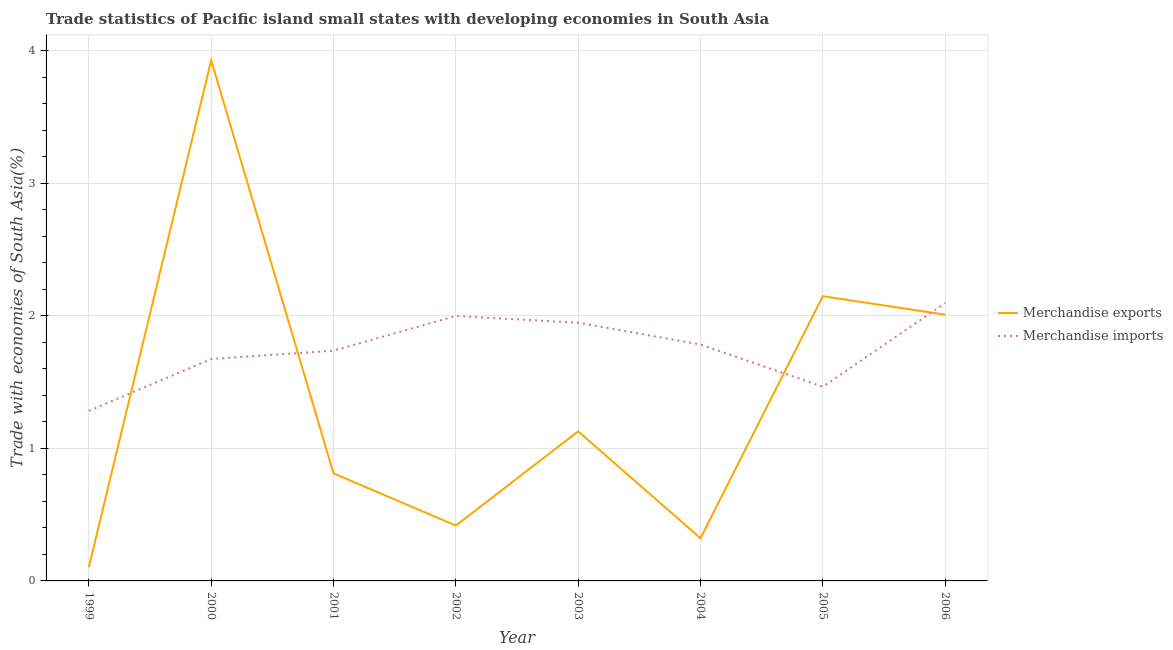How many different coloured lines are there?
Provide a succinct answer. 2. What is the merchandise exports in 2005?
Provide a succinct answer. 2.15. Across all years, what is the maximum merchandise imports?
Keep it short and to the point. 2.09. Across all years, what is the minimum merchandise exports?
Your response must be concise. 0.1. In which year was the merchandise imports maximum?
Your answer should be very brief. 2006. What is the total merchandise imports in the graph?
Your answer should be compact. 13.98. What is the difference between the merchandise imports in 2004 and that in 2005?
Keep it short and to the point. 0.32. What is the difference between the merchandise exports in 1999 and the merchandise imports in 2005?
Provide a succinct answer. -1.36. What is the average merchandise exports per year?
Your answer should be very brief. 1.36. In the year 2002, what is the difference between the merchandise imports and merchandise exports?
Your response must be concise. 1.58. In how many years, is the merchandise imports greater than 1.6 %?
Provide a succinct answer. 6. What is the ratio of the merchandise exports in 1999 to that in 2001?
Your response must be concise. 0.13. Is the merchandise imports in 2000 less than that in 2001?
Your response must be concise. Yes. Is the difference between the merchandise imports in 1999 and 2000 greater than the difference between the merchandise exports in 1999 and 2000?
Your answer should be compact. Yes. What is the difference between the highest and the second highest merchandise imports?
Offer a very short reply. 0.1. What is the difference between the highest and the lowest merchandise imports?
Ensure brevity in your answer.  0.81. In how many years, is the merchandise exports greater than the average merchandise exports taken over all years?
Your answer should be very brief. 3. Is the sum of the merchandise exports in 2001 and 2003 greater than the maximum merchandise imports across all years?
Make the answer very short. No. Does the merchandise exports monotonically increase over the years?
Offer a terse response. No. Is the merchandise exports strictly less than the merchandise imports over the years?
Make the answer very short. No. Where does the legend appear in the graph?
Offer a very short reply. Center right. How many legend labels are there?
Offer a terse response. 2. How are the legend labels stacked?
Ensure brevity in your answer.  Vertical. What is the title of the graph?
Your answer should be very brief. Trade statistics of Pacific island small states with developing economies in South Asia. What is the label or title of the X-axis?
Offer a terse response. Year. What is the label or title of the Y-axis?
Your answer should be compact. Trade with economies of South Asia(%). What is the Trade with economies of South Asia(%) in Merchandise exports in 1999?
Provide a short and direct response. 0.1. What is the Trade with economies of South Asia(%) of Merchandise imports in 1999?
Provide a succinct answer. 1.28. What is the Trade with economies of South Asia(%) of Merchandise exports in 2000?
Provide a succinct answer. 3.93. What is the Trade with economies of South Asia(%) in Merchandise imports in 2000?
Your answer should be compact. 1.67. What is the Trade with economies of South Asia(%) of Merchandise exports in 2001?
Offer a very short reply. 0.81. What is the Trade with economies of South Asia(%) of Merchandise imports in 2001?
Offer a very short reply. 1.74. What is the Trade with economies of South Asia(%) of Merchandise exports in 2002?
Offer a very short reply. 0.42. What is the Trade with economies of South Asia(%) in Merchandise imports in 2002?
Give a very brief answer. 2. What is the Trade with economies of South Asia(%) in Merchandise exports in 2003?
Your answer should be compact. 1.13. What is the Trade with economies of South Asia(%) in Merchandise imports in 2003?
Provide a succinct answer. 1.95. What is the Trade with economies of South Asia(%) in Merchandise exports in 2004?
Offer a very short reply. 0.32. What is the Trade with economies of South Asia(%) of Merchandise imports in 2004?
Give a very brief answer. 1.78. What is the Trade with economies of South Asia(%) in Merchandise exports in 2005?
Your answer should be very brief. 2.15. What is the Trade with economies of South Asia(%) of Merchandise imports in 2005?
Provide a succinct answer. 1.46. What is the Trade with economies of South Asia(%) of Merchandise exports in 2006?
Make the answer very short. 2.01. What is the Trade with economies of South Asia(%) in Merchandise imports in 2006?
Offer a terse response. 2.09. Across all years, what is the maximum Trade with economies of South Asia(%) of Merchandise exports?
Make the answer very short. 3.93. Across all years, what is the maximum Trade with economies of South Asia(%) in Merchandise imports?
Offer a terse response. 2.09. Across all years, what is the minimum Trade with economies of South Asia(%) in Merchandise exports?
Your answer should be compact. 0.1. Across all years, what is the minimum Trade with economies of South Asia(%) in Merchandise imports?
Offer a terse response. 1.28. What is the total Trade with economies of South Asia(%) in Merchandise exports in the graph?
Your answer should be very brief. 10.86. What is the total Trade with economies of South Asia(%) of Merchandise imports in the graph?
Your response must be concise. 13.98. What is the difference between the Trade with economies of South Asia(%) of Merchandise exports in 1999 and that in 2000?
Give a very brief answer. -3.82. What is the difference between the Trade with economies of South Asia(%) of Merchandise imports in 1999 and that in 2000?
Your answer should be compact. -0.39. What is the difference between the Trade with economies of South Asia(%) in Merchandise exports in 1999 and that in 2001?
Ensure brevity in your answer.  -0.71. What is the difference between the Trade with economies of South Asia(%) of Merchandise imports in 1999 and that in 2001?
Ensure brevity in your answer.  -0.45. What is the difference between the Trade with economies of South Asia(%) in Merchandise exports in 1999 and that in 2002?
Your answer should be compact. -0.31. What is the difference between the Trade with economies of South Asia(%) of Merchandise imports in 1999 and that in 2002?
Ensure brevity in your answer.  -0.72. What is the difference between the Trade with economies of South Asia(%) in Merchandise exports in 1999 and that in 2003?
Give a very brief answer. -1.02. What is the difference between the Trade with economies of South Asia(%) in Merchandise imports in 1999 and that in 2003?
Ensure brevity in your answer.  -0.66. What is the difference between the Trade with economies of South Asia(%) in Merchandise exports in 1999 and that in 2004?
Your response must be concise. -0.22. What is the difference between the Trade with economies of South Asia(%) of Merchandise imports in 1999 and that in 2004?
Provide a short and direct response. -0.5. What is the difference between the Trade with economies of South Asia(%) in Merchandise exports in 1999 and that in 2005?
Give a very brief answer. -2.04. What is the difference between the Trade with economies of South Asia(%) of Merchandise imports in 1999 and that in 2005?
Make the answer very short. -0.18. What is the difference between the Trade with economies of South Asia(%) of Merchandise exports in 1999 and that in 2006?
Your answer should be very brief. -1.9. What is the difference between the Trade with economies of South Asia(%) of Merchandise imports in 1999 and that in 2006?
Provide a succinct answer. -0.81. What is the difference between the Trade with economies of South Asia(%) of Merchandise exports in 2000 and that in 2001?
Your answer should be very brief. 3.12. What is the difference between the Trade with economies of South Asia(%) of Merchandise imports in 2000 and that in 2001?
Your answer should be very brief. -0.06. What is the difference between the Trade with economies of South Asia(%) in Merchandise exports in 2000 and that in 2002?
Provide a short and direct response. 3.51. What is the difference between the Trade with economies of South Asia(%) of Merchandise imports in 2000 and that in 2002?
Give a very brief answer. -0.32. What is the difference between the Trade with economies of South Asia(%) of Merchandise exports in 2000 and that in 2003?
Your answer should be compact. 2.8. What is the difference between the Trade with economies of South Asia(%) in Merchandise imports in 2000 and that in 2003?
Offer a very short reply. -0.27. What is the difference between the Trade with economies of South Asia(%) of Merchandise exports in 2000 and that in 2004?
Provide a succinct answer. 3.6. What is the difference between the Trade with economies of South Asia(%) of Merchandise imports in 2000 and that in 2004?
Provide a succinct answer. -0.11. What is the difference between the Trade with economies of South Asia(%) in Merchandise exports in 2000 and that in 2005?
Make the answer very short. 1.78. What is the difference between the Trade with economies of South Asia(%) in Merchandise imports in 2000 and that in 2005?
Your answer should be very brief. 0.21. What is the difference between the Trade with economies of South Asia(%) of Merchandise exports in 2000 and that in 2006?
Offer a very short reply. 1.92. What is the difference between the Trade with economies of South Asia(%) in Merchandise imports in 2000 and that in 2006?
Ensure brevity in your answer.  -0.42. What is the difference between the Trade with economies of South Asia(%) of Merchandise exports in 2001 and that in 2002?
Provide a short and direct response. 0.39. What is the difference between the Trade with economies of South Asia(%) in Merchandise imports in 2001 and that in 2002?
Make the answer very short. -0.26. What is the difference between the Trade with economies of South Asia(%) in Merchandise exports in 2001 and that in 2003?
Offer a terse response. -0.32. What is the difference between the Trade with economies of South Asia(%) of Merchandise imports in 2001 and that in 2003?
Offer a very short reply. -0.21. What is the difference between the Trade with economies of South Asia(%) in Merchandise exports in 2001 and that in 2004?
Ensure brevity in your answer.  0.49. What is the difference between the Trade with economies of South Asia(%) in Merchandise imports in 2001 and that in 2004?
Offer a very short reply. -0.05. What is the difference between the Trade with economies of South Asia(%) in Merchandise exports in 2001 and that in 2005?
Give a very brief answer. -1.34. What is the difference between the Trade with economies of South Asia(%) of Merchandise imports in 2001 and that in 2005?
Offer a terse response. 0.27. What is the difference between the Trade with economies of South Asia(%) of Merchandise exports in 2001 and that in 2006?
Provide a short and direct response. -1.2. What is the difference between the Trade with economies of South Asia(%) in Merchandise imports in 2001 and that in 2006?
Offer a terse response. -0.36. What is the difference between the Trade with economies of South Asia(%) of Merchandise exports in 2002 and that in 2003?
Offer a very short reply. -0.71. What is the difference between the Trade with economies of South Asia(%) in Merchandise imports in 2002 and that in 2003?
Your answer should be compact. 0.05. What is the difference between the Trade with economies of South Asia(%) in Merchandise exports in 2002 and that in 2004?
Keep it short and to the point. 0.1. What is the difference between the Trade with economies of South Asia(%) in Merchandise imports in 2002 and that in 2004?
Provide a short and direct response. 0.22. What is the difference between the Trade with economies of South Asia(%) of Merchandise exports in 2002 and that in 2005?
Offer a terse response. -1.73. What is the difference between the Trade with economies of South Asia(%) in Merchandise imports in 2002 and that in 2005?
Make the answer very short. 0.53. What is the difference between the Trade with economies of South Asia(%) of Merchandise exports in 2002 and that in 2006?
Provide a succinct answer. -1.59. What is the difference between the Trade with economies of South Asia(%) in Merchandise imports in 2002 and that in 2006?
Ensure brevity in your answer.  -0.1. What is the difference between the Trade with economies of South Asia(%) in Merchandise exports in 2003 and that in 2004?
Your answer should be compact. 0.81. What is the difference between the Trade with economies of South Asia(%) in Merchandise imports in 2003 and that in 2004?
Give a very brief answer. 0.16. What is the difference between the Trade with economies of South Asia(%) in Merchandise exports in 2003 and that in 2005?
Ensure brevity in your answer.  -1.02. What is the difference between the Trade with economies of South Asia(%) in Merchandise imports in 2003 and that in 2005?
Your response must be concise. 0.48. What is the difference between the Trade with economies of South Asia(%) in Merchandise exports in 2003 and that in 2006?
Offer a terse response. -0.88. What is the difference between the Trade with economies of South Asia(%) of Merchandise imports in 2003 and that in 2006?
Ensure brevity in your answer.  -0.15. What is the difference between the Trade with economies of South Asia(%) in Merchandise exports in 2004 and that in 2005?
Offer a terse response. -1.83. What is the difference between the Trade with economies of South Asia(%) of Merchandise imports in 2004 and that in 2005?
Make the answer very short. 0.32. What is the difference between the Trade with economies of South Asia(%) of Merchandise exports in 2004 and that in 2006?
Make the answer very short. -1.69. What is the difference between the Trade with economies of South Asia(%) in Merchandise imports in 2004 and that in 2006?
Provide a succinct answer. -0.31. What is the difference between the Trade with economies of South Asia(%) in Merchandise exports in 2005 and that in 2006?
Offer a very short reply. 0.14. What is the difference between the Trade with economies of South Asia(%) in Merchandise imports in 2005 and that in 2006?
Ensure brevity in your answer.  -0.63. What is the difference between the Trade with economies of South Asia(%) in Merchandise exports in 1999 and the Trade with economies of South Asia(%) in Merchandise imports in 2000?
Offer a terse response. -1.57. What is the difference between the Trade with economies of South Asia(%) of Merchandise exports in 1999 and the Trade with economies of South Asia(%) of Merchandise imports in 2001?
Provide a succinct answer. -1.63. What is the difference between the Trade with economies of South Asia(%) in Merchandise exports in 1999 and the Trade with economies of South Asia(%) in Merchandise imports in 2002?
Provide a short and direct response. -1.89. What is the difference between the Trade with economies of South Asia(%) in Merchandise exports in 1999 and the Trade with economies of South Asia(%) in Merchandise imports in 2003?
Your answer should be compact. -1.84. What is the difference between the Trade with economies of South Asia(%) in Merchandise exports in 1999 and the Trade with economies of South Asia(%) in Merchandise imports in 2004?
Keep it short and to the point. -1.68. What is the difference between the Trade with economies of South Asia(%) in Merchandise exports in 1999 and the Trade with economies of South Asia(%) in Merchandise imports in 2005?
Offer a terse response. -1.36. What is the difference between the Trade with economies of South Asia(%) of Merchandise exports in 1999 and the Trade with economies of South Asia(%) of Merchandise imports in 2006?
Your response must be concise. -1.99. What is the difference between the Trade with economies of South Asia(%) of Merchandise exports in 2000 and the Trade with economies of South Asia(%) of Merchandise imports in 2001?
Provide a succinct answer. 2.19. What is the difference between the Trade with economies of South Asia(%) of Merchandise exports in 2000 and the Trade with economies of South Asia(%) of Merchandise imports in 2002?
Provide a succinct answer. 1.93. What is the difference between the Trade with economies of South Asia(%) of Merchandise exports in 2000 and the Trade with economies of South Asia(%) of Merchandise imports in 2003?
Your response must be concise. 1.98. What is the difference between the Trade with economies of South Asia(%) of Merchandise exports in 2000 and the Trade with economies of South Asia(%) of Merchandise imports in 2004?
Keep it short and to the point. 2.14. What is the difference between the Trade with economies of South Asia(%) in Merchandise exports in 2000 and the Trade with economies of South Asia(%) in Merchandise imports in 2005?
Provide a succinct answer. 2.46. What is the difference between the Trade with economies of South Asia(%) of Merchandise exports in 2000 and the Trade with economies of South Asia(%) of Merchandise imports in 2006?
Ensure brevity in your answer.  1.83. What is the difference between the Trade with economies of South Asia(%) of Merchandise exports in 2001 and the Trade with economies of South Asia(%) of Merchandise imports in 2002?
Offer a terse response. -1.19. What is the difference between the Trade with economies of South Asia(%) of Merchandise exports in 2001 and the Trade with economies of South Asia(%) of Merchandise imports in 2003?
Provide a short and direct response. -1.14. What is the difference between the Trade with economies of South Asia(%) of Merchandise exports in 2001 and the Trade with economies of South Asia(%) of Merchandise imports in 2004?
Offer a terse response. -0.97. What is the difference between the Trade with economies of South Asia(%) in Merchandise exports in 2001 and the Trade with economies of South Asia(%) in Merchandise imports in 2005?
Your response must be concise. -0.65. What is the difference between the Trade with economies of South Asia(%) in Merchandise exports in 2001 and the Trade with economies of South Asia(%) in Merchandise imports in 2006?
Keep it short and to the point. -1.28. What is the difference between the Trade with economies of South Asia(%) in Merchandise exports in 2002 and the Trade with economies of South Asia(%) in Merchandise imports in 2003?
Keep it short and to the point. -1.53. What is the difference between the Trade with economies of South Asia(%) of Merchandise exports in 2002 and the Trade with economies of South Asia(%) of Merchandise imports in 2004?
Provide a short and direct response. -1.37. What is the difference between the Trade with economies of South Asia(%) of Merchandise exports in 2002 and the Trade with economies of South Asia(%) of Merchandise imports in 2005?
Your response must be concise. -1.05. What is the difference between the Trade with economies of South Asia(%) of Merchandise exports in 2002 and the Trade with economies of South Asia(%) of Merchandise imports in 2006?
Provide a short and direct response. -1.68. What is the difference between the Trade with economies of South Asia(%) of Merchandise exports in 2003 and the Trade with economies of South Asia(%) of Merchandise imports in 2004?
Your answer should be very brief. -0.65. What is the difference between the Trade with economies of South Asia(%) in Merchandise exports in 2003 and the Trade with economies of South Asia(%) in Merchandise imports in 2005?
Offer a very short reply. -0.34. What is the difference between the Trade with economies of South Asia(%) of Merchandise exports in 2003 and the Trade with economies of South Asia(%) of Merchandise imports in 2006?
Give a very brief answer. -0.97. What is the difference between the Trade with economies of South Asia(%) of Merchandise exports in 2004 and the Trade with economies of South Asia(%) of Merchandise imports in 2005?
Ensure brevity in your answer.  -1.14. What is the difference between the Trade with economies of South Asia(%) of Merchandise exports in 2004 and the Trade with economies of South Asia(%) of Merchandise imports in 2006?
Your answer should be very brief. -1.77. What is the difference between the Trade with economies of South Asia(%) in Merchandise exports in 2005 and the Trade with economies of South Asia(%) in Merchandise imports in 2006?
Keep it short and to the point. 0.05. What is the average Trade with economies of South Asia(%) of Merchandise exports per year?
Offer a terse response. 1.36. What is the average Trade with economies of South Asia(%) of Merchandise imports per year?
Keep it short and to the point. 1.75. In the year 1999, what is the difference between the Trade with economies of South Asia(%) of Merchandise exports and Trade with economies of South Asia(%) of Merchandise imports?
Ensure brevity in your answer.  -1.18. In the year 2000, what is the difference between the Trade with economies of South Asia(%) in Merchandise exports and Trade with economies of South Asia(%) in Merchandise imports?
Your answer should be compact. 2.25. In the year 2001, what is the difference between the Trade with economies of South Asia(%) in Merchandise exports and Trade with economies of South Asia(%) in Merchandise imports?
Keep it short and to the point. -0.93. In the year 2002, what is the difference between the Trade with economies of South Asia(%) in Merchandise exports and Trade with economies of South Asia(%) in Merchandise imports?
Provide a succinct answer. -1.58. In the year 2003, what is the difference between the Trade with economies of South Asia(%) of Merchandise exports and Trade with economies of South Asia(%) of Merchandise imports?
Your answer should be compact. -0.82. In the year 2004, what is the difference between the Trade with economies of South Asia(%) of Merchandise exports and Trade with economies of South Asia(%) of Merchandise imports?
Your answer should be compact. -1.46. In the year 2005, what is the difference between the Trade with economies of South Asia(%) in Merchandise exports and Trade with economies of South Asia(%) in Merchandise imports?
Keep it short and to the point. 0.68. In the year 2006, what is the difference between the Trade with economies of South Asia(%) of Merchandise exports and Trade with economies of South Asia(%) of Merchandise imports?
Your answer should be very brief. -0.09. What is the ratio of the Trade with economies of South Asia(%) of Merchandise exports in 1999 to that in 2000?
Offer a very short reply. 0.03. What is the ratio of the Trade with economies of South Asia(%) in Merchandise imports in 1999 to that in 2000?
Your answer should be compact. 0.77. What is the ratio of the Trade with economies of South Asia(%) in Merchandise exports in 1999 to that in 2001?
Keep it short and to the point. 0.13. What is the ratio of the Trade with economies of South Asia(%) in Merchandise imports in 1999 to that in 2001?
Your answer should be compact. 0.74. What is the ratio of the Trade with economies of South Asia(%) of Merchandise exports in 1999 to that in 2002?
Make the answer very short. 0.25. What is the ratio of the Trade with economies of South Asia(%) in Merchandise imports in 1999 to that in 2002?
Keep it short and to the point. 0.64. What is the ratio of the Trade with economies of South Asia(%) in Merchandise exports in 1999 to that in 2003?
Your response must be concise. 0.09. What is the ratio of the Trade with economies of South Asia(%) in Merchandise imports in 1999 to that in 2003?
Make the answer very short. 0.66. What is the ratio of the Trade with economies of South Asia(%) in Merchandise exports in 1999 to that in 2004?
Provide a succinct answer. 0.32. What is the ratio of the Trade with economies of South Asia(%) of Merchandise imports in 1999 to that in 2004?
Your answer should be very brief. 0.72. What is the ratio of the Trade with economies of South Asia(%) in Merchandise exports in 1999 to that in 2005?
Keep it short and to the point. 0.05. What is the ratio of the Trade with economies of South Asia(%) of Merchandise imports in 1999 to that in 2005?
Your answer should be very brief. 0.88. What is the ratio of the Trade with economies of South Asia(%) in Merchandise exports in 1999 to that in 2006?
Your response must be concise. 0.05. What is the ratio of the Trade with economies of South Asia(%) of Merchandise imports in 1999 to that in 2006?
Offer a terse response. 0.61. What is the ratio of the Trade with economies of South Asia(%) in Merchandise exports in 2000 to that in 2001?
Provide a succinct answer. 4.84. What is the ratio of the Trade with economies of South Asia(%) of Merchandise imports in 2000 to that in 2001?
Offer a terse response. 0.96. What is the ratio of the Trade with economies of South Asia(%) in Merchandise exports in 2000 to that in 2002?
Your response must be concise. 9.41. What is the ratio of the Trade with economies of South Asia(%) of Merchandise imports in 2000 to that in 2002?
Ensure brevity in your answer.  0.84. What is the ratio of the Trade with economies of South Asia(%) of Merchandise exports in 2000 to that in 2003?
Your answer should be very brief. 3.48. What is the ratio of the Trade with economies of South Asia(%) in Merchandise imports in 2000 to that in 2003?
Your answer should be very brief. 0.86. What is the ratio of the Trade with economies of South Asia(%) of Merchandise exports in 2000 to that in 2004?
Provide a short and direct response. 12.2. What is the ratio of the Trade with economies of South Asia(%) in Merchandise imports in 2000 to that in 2004?
Offer a very short reply. 0.94. What is the ratio of the Trade with economies of South Asia(%) of Merchandise exports in 2000 to that in 2005?
Give a very brief answer. 1.83. What is the ratio of the Trade with economies of South Asia(%) of Merchandise imports in 2000 to that in 2005?
Give a very brief answer. 1.14. What is the ratio of the Trade with economies of South Asia(%) in Merchandise exports in 2000 to that in 2006?
Your answer should be very brief. 1.96. What is the ratio of the Trade with economies of South Asia(%) of Merchandise imports in 2000 to that in 2006?
Offer a terse response. 0.8. What is the ratio of the Trade with economies of South Asia(%) in Merchandise exports in 2001 to that in 2002?
Make the answer very short. 1.94. What is the ratio of the Trade with economies of South Asia(%) of Merchandise imports in 2001 to that in 2002?
Keep it short and to the point. 0.87. What is the ratio of the Trade with economies of South Asia(%) in Merchandise exports in 2001 to that in 2003?
Provide a short and direct response. 0.72. What is the ratio of the Trade with economies of South Asia(%) of Merchandise imports in 2001 to that in 2003?
Your response must be concise. 0.89. What is the ratio of the Trade with economies of South Asia(%) of Merchandise exports in 2001 to that in 2004?
Your response must be concise. 2.52. What is the ratio of the Trade with economies of South Asia(%) of Merchandise imports in 2001 to that in 2004?
Your answer should be compact. 0.97. What is the ratio of the Trade with economies of South Asia(%) of Merchandise exports in 2001 to that in 2005?
Your answer should be very brief. 0.38. What is the ratio of the Trade with economies of South Asia(%) in Merchandise imports in 2001 to that in 2005?
Ensure brevity in your answer.  1.19. What is the ratio of the Trade with economies of South Asia(%) of Merchandise exports in 2001 to that in 2006?
Provide a succinct answer. 0.4. What is the ratio of the Trade with economies of South Asia(%) of Merchandise imports in 2001 to that in 2006?
Your response must be concise. 0.83. What is the ratio of the Trade with economies of South Asia(%) of Merchandise exports in 2002 to that in 2003?
Keep it short and to the point. 0.37. What is the ratio of the Trade with economies of South Asia(%) of Merchandise imports in 2002 to that in 2003?
Ensure brevity in your answer.  1.03. What is the ratio of the Trade with economies of South Asia(%) in Merchandise exports in 2002 to that in 2004?
Your answer should be compact. 1.3. What is the ratio of the Trade with economies of South Asia(%) in Merchandise imports in 2002 to that in 2004?
Your response must be concise. 1.12. What is the ratio of the Trade with economies of South Asia(%) of Merchandise exports in 2002 to that in 2005?
Ensure brevity in your answer.  0.19. What is the ratio of the Trade with economies of South Asia(%) in Merchandise imports in 2002 to that in 2005?
Provide a succinct answer. 1.36. What is the ratio of the Trade with economies of South Asia(%) in Merchandise exports in 2002 to that in 2006?
Offer a very short reply. 0.21. What is the ratio of the Trade with economies of South Asia(%) in Merchandise imports in 2002 to that in 2006?
Offer a very short reply. 0.95. What is the ratio of the Trade with economies of South Asia(%) of Merchandise exports in 2003 to that in 2004?
Your answer should be very brief. 3.5. What is the ratio of the Trade with economies of South Asia(%) in Merchandise imports in 2003 to that in 2004?
Your answer should be very brief. 1.09. What is the ratio of the Trade with economies of South Asia(%) in Merchandise exports in 2003 to that in 2005?
Give a very brief answer. 0.53. What is the ratio of the Trade with economies of South Asia(%) in Merchandise imports in 2003 to that in 2005?
Offer a very short reply. 1.33. What is the ratio of the Trade with economies of South Asia(%) in Merchandise exports in 2003 to that in 2006?
Ensure brevity in your answer.  0.56. What is the ratio of the Trade with economies of South Asia(%) in Merchandise imports in 2003 to that in 2006?
Your response must be concise. 0.93. What is the ratio of the Trade with economies of South Asia(%) of Merchandise exports in 2004 to that in 2005?
Your response must be concise. 0.15. What is the ratio of the Trade with economies of South Asia(%) of Merchandise imports in 2004 to that in 2005?
Ensure brevity in your answer.  1.22. What is the ratio of the Trade with economies of South Asia(%) of Merchandise exports in 2004 to that in 2006?
Offer a very short reply. 0.16. What is the ratio of the Trade with economies of South Asia(%) of Merchandise imports in 2004 to that in 2006?
Keep it short and to the point. 0.85. What is the ratio of the Trade with economies of South Asia(%) of Merchandise exports in 2005 to that in 2006?
Offer a terse response. 1.07. What is the ratio of the Trade with economies of South Asia(%) in Merchandise imports in 2005 to that in 2006?
Offer a very short reply. 0.7. What is the difference between the highest and the second highest Trade with economies of South Asia(%) in Merchandise exports?
Your answer should be very brief. 1.78. What is the difference between the highest and the second highest Trade with economies of South Asia(%) in Merchandise imports?
Keep it short and to the point. 0.1. What is the difference between the highest and the lowest Trade with economies of South Asia(%) of Merchandise exports?
Ensure brevity in your answer.  3.82. What is the difference between the highest and the lowest Trade with economies of South Asia(%) in Merchandise imports?
Your answer should be very brief. 0.81. 